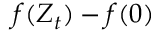Convert formula to latex. <formula><loc_0><loc_0><loc_500><loc_500>f ( Z _ { t } ) - f ( 0 )</formula> 